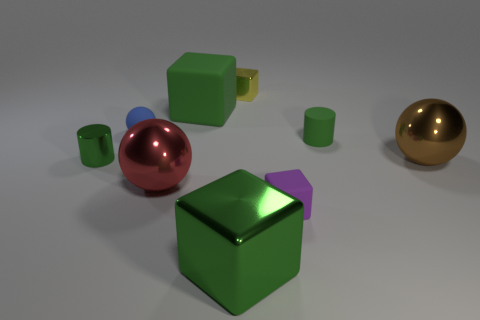What is the material of the other block that is the same color as the big matte block?
Keep it short and to the point. Metal. What size is the metallic block that is the same color as the metal cylinder?
Offer a very short reply. Large. Is the size of the blue sphere the same as the green object that is on the left side of the small blue matte object?
Ensure brevity in your answer.  Yes. There is a metal thing that is behind the cylinder on the left side of the red ball; what size is it?
Provide a short and direct response. Small. What number of large cubes have the same material as the small yellow cube?
Give a very brief answer. 1. Is there a big brown metallic object?
Provide a short and direct response. Yes. What is the size of the metallic block that is behind the red metal thing?
Ensure brevity in your answer.  Small. How many other big balls have the same color as the matte sphere?
Ensure brevity in your answer.  0. How many cylinders are large cyan rubber things or big brown metal objects?
Your answer should be compact. 0. There is a small matte thing that is on the right side of the blue thing and behind the purple rubber cube; what is its shape?
Give a very brief answer. Cylinder. 